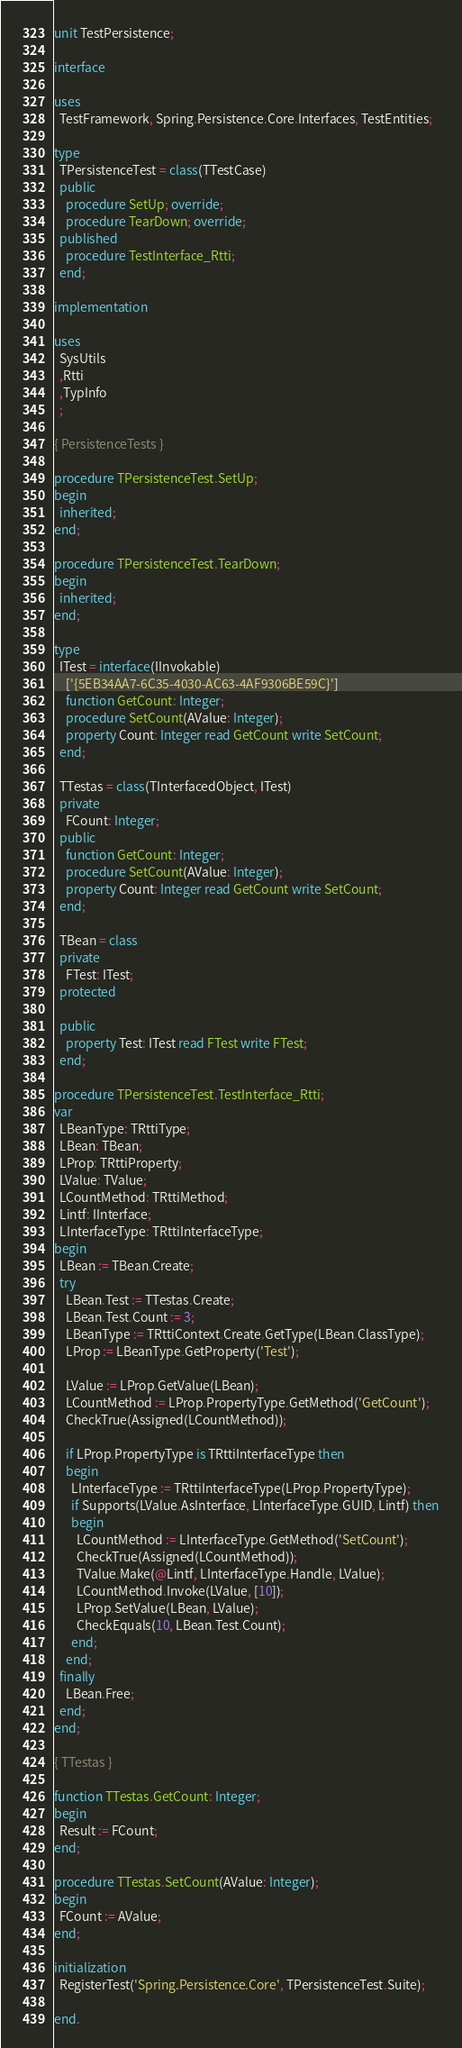<code> <loc_0><loc_0><loc_500><loc_500><_Pascal_>unit TestPersistence;

interface

uses
  TestFramework, Spring.Persistence.Core.Interfaces, TestEntities;

type
  TPersistenceTest = class(TTestCase)
  public
    procedure SetUp; override;
    procedure TearDown; override;
  published
    procedure TestInterface_Rtti;
  end;

implementation

uses
  SysUtils
  ,Rtti
  ,TypInfo
  ;

{ PersistenceTests }

procedure TPersistenceTest.SetUp;
begin
  inherited;
end;

procedure TPersistenceTest.TearDown;
begin
  inherited;
end;

type
  ITest = interface(IInvokable)
    ['{5EB34AA7-6C35-4030-AC63-4AF9306BE59C}']
    function GetCount: Integer;
    procedure SetCount(AValue: Integer);
    property Count: Integer read GetCount write SetCount;
  end;

  TTestas = class(TInterfacedObject, ITest)
  private
    FCount: Integer;
  public
    function GetCount: Integer;
    procedure SetCount(AValue: Integer);
    property Count: Integer read GetCount write SetCount;
  end;

  TBean = class
  private
    FTest: ITest;
  protected

  public
    property Test: ITest read FTest write FTest;
  end;

procedure TPersistenceTest.TestInterface_Rtti;
var
  LBeanType: TRttiType;
  LBean: TBean;
  LProp: TRttiProperty;
  LValue: TValue;
  LCountMethod: TRttiMethod;
  Lintf: IInterface;
  LInterfaceType: TRttiInterfaceType;
begin
  LBean := TBean.Create;
  try
    LBean.Test := TTestas.Create;
    LBean.Test.Count := 3;
    LBeanType := TRttiContext.Create.GetType(LBean.ClassType);
    LProp := LBeanType.GetProperty('Test');

    LValue := LProp.GetValue(LBean);
    LCountMethod := LProp.PropertyType.GetMethod('GetCount');
    CheckTrue(Assigned(LCountMethod));

    if LProp.PropertyType is TRttiInterfaceType then
    begin
      LInterfaceType := TRttiInterfaceType(LProp.PropertyType);
      if Supports(LValue.AsInterface, LInterfaceType.GUID, Lintf) then
      begin
        LCountMethod := LInterfaceType.GetMethod('SetCount');
        CheckTrue(Assigned(LCountMethod));
        TValue.Make(@Lintf, LInterfaceType.Handle, LValue);
        LCountMethod.Invoke(LValue, [10]);
        LProp.SetValue(LBean, LValue);
        CheckEquals(10, LBean.Test.Count);
      end;
    end;
  finally
    LBean.Free;
  end;
end;

{ TTestas }

function TTestas.GetCount: Integer;
begin
  Result := FCount;
end;

procedure TTestas.SetCount(AValue: Integer);
begin
  FCount := AValue;
end;

initialization
  RegisterTest('Spring.Persistence.Core', TPersistenceTest.Suite);

end.
</code> 